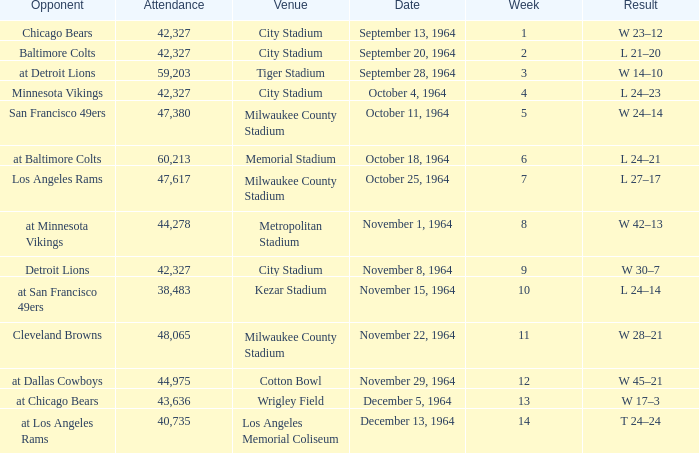What is the average week of the game on November 22, 1964 attended by 48,065? None. 